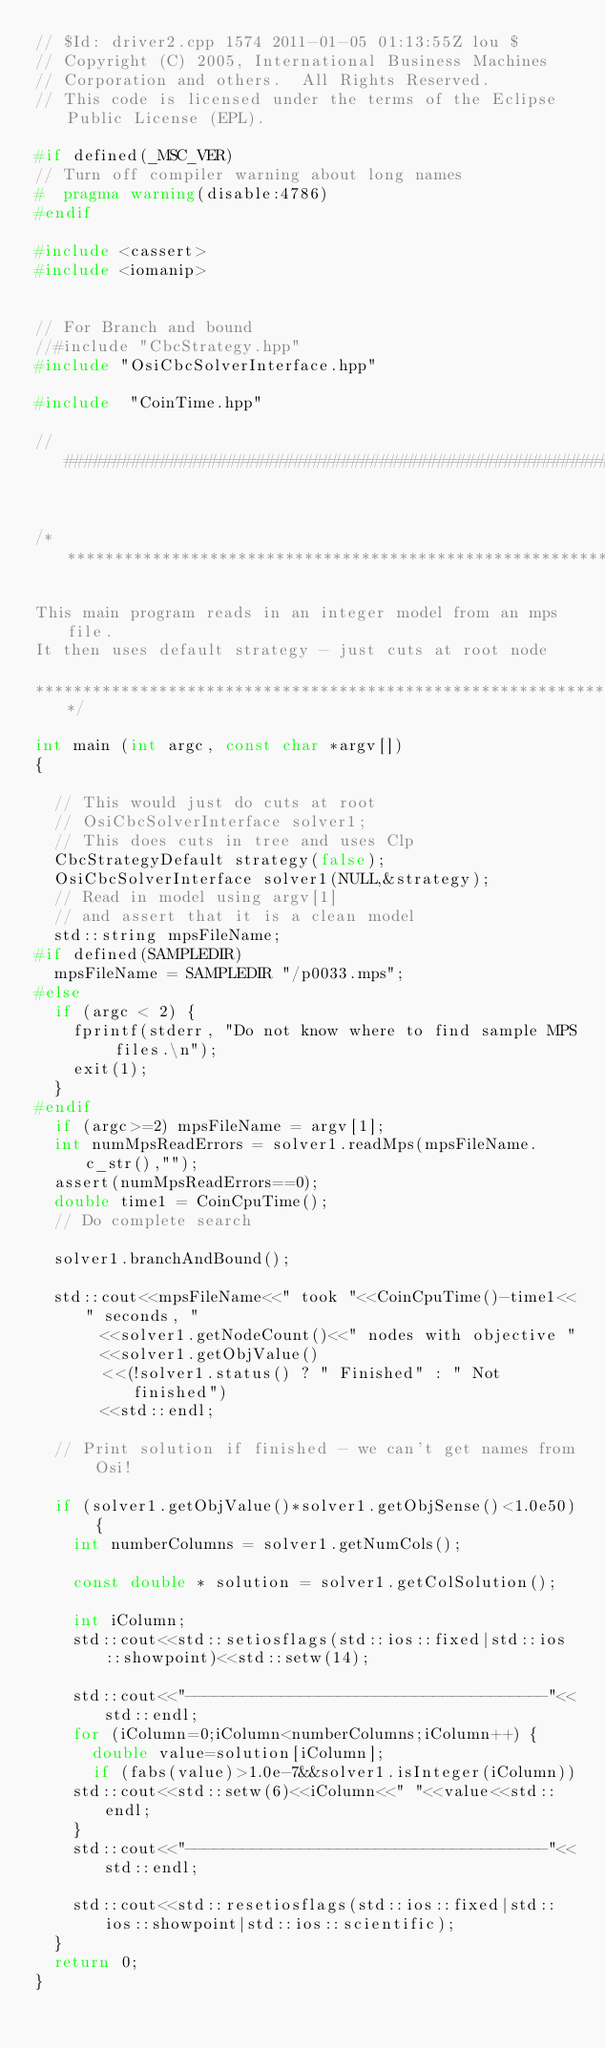Convert code to text. <code><loc_0><loc_0><loc_500><loc_500><_C++_>// $Id: driver2.cpp 1574 2011-01-05 01:13:55Z lou $
// Copyright (C) 2005, International Business Machines
// Corporation and others.  All Rights Reserved.
// This code is licensed under the terms of the Eclipse Public License (EPL).

#if defined(_MSC_VER)
// Turn off compiler warning about long names
#  pragma warning(disable:4786)
#endif

#include <cassert>
#include <iomanip>


// For Branch and bound
//#include "CbcStrategy.hpp"
#include "OsiCbcSolverInterface.hpp"

#include  "CoinTime.hpp"

//#############################################################################


/************************************************************************

This main program reads in an integer model from an mps file.
It then uses default strategy - just cuts at root node

************************************************************************/

int main (int argc, const char *argv[])
{

  // This would just do cuts at root
  // OsiCbcSolverInterface solver1;
  // This does cuts in tree and uses Clp
  CbcStrategyDefault strategy(false);
  OsiCbcSolverInterface solver1(NULL,&strategy);
  // Read in model using argv[1]
  // and assert that it is a clean model
  std::string mpsFileName;
#if defined(SAMPLEDIR)
  mpsFileName = SAMPLEDIR "/p0033.mps";
#else
  if (argc < 2) {
    fprintf(stderr, "Do not know where to find sample MPS files.\n");
    exit(1);
  }
#endif
  if (argc>=2) mpsFileName = argv[1];
  int numMpsReadErrors = solver1.readMps(mpsFileName.c_str(),"");
  assert(numMpsReadErrors==0);
  double time1 = CoinCpuTime();
  // Do complete search
  
  solver1.branchAndBound();

  std::cout<<mpsFileName<<" took "<<CoinCpuTime()-time1<<" seconds, "
	   <<solver1.getNodeCount()<<" nodes with objective "
	   <<solver1.getObjValue()
	   <<(!solver1.status() ? " Finished" : " Not finished")
	   <<std::endl;

  // Print solution if finished - we can't get names from Osi!

  if (solver1.getObjValue()*solver1.getObjSense()<1.0e50) {
    int numberColumns = solver1.getNumCols();
    
    const double * solution = solver1.getColSolution();
    
    int iColumn;
    std::cout<<std::setiosflags(std::ios::fixed|std::ios::showpoint)<<std::setw(14);
    
    std::cout<<"--------------------------------------"<<std::endl;
    for (iColumn=0;iColumn<numberColumns;iColumn++) {
      double value=solution[iColumn];
      if (fabs(value)>1.0e-7&&solver1.isInteger(iColumn)) 
	std::cout<<std::setw(6)<<iColumn<<" "<<value<<std::endl;
    }
    std::cout<<"--------------------------------------"<<std::endl;
  
    std::cout<<std::resetiosflags(std::ios::fixed|std::ios::showpoint|std::ios::scientific);
  }
  return 0;
}    
</code> 